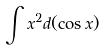Convert formula to latex. <formula><loc_0><loc_0><loc_500><loc_500>\int x ^ { 2 } d ( \cos x )</formula> 